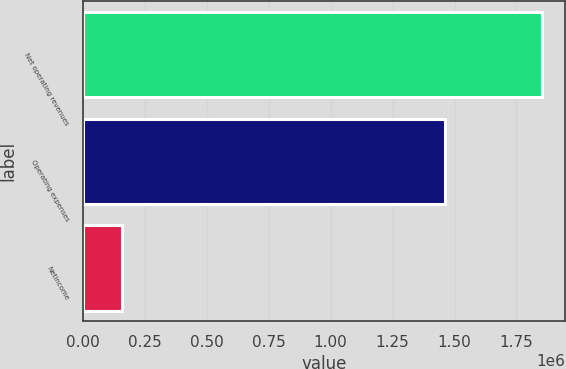Convert chart to OTSL. <chart><loc_0><loc_0><loc_500><loc_500><bar_chart><fcel>Net operating revenues<fcel>Operating expenses<fcel>Netincome<nl><fcel>1.85463e+06<fcel>1.4633e+06<fcel>157329<nl></chart> 